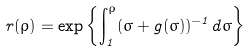<formula> <loc_0><loc_0><loc_500><loc_500>r ( \rho ) = \exp \left \{ \int _ { 1 } ^ { \rho } ( \sigma + g ( \sigma ) ) ^ { - 1 } d \sigma \right \}</formula> 